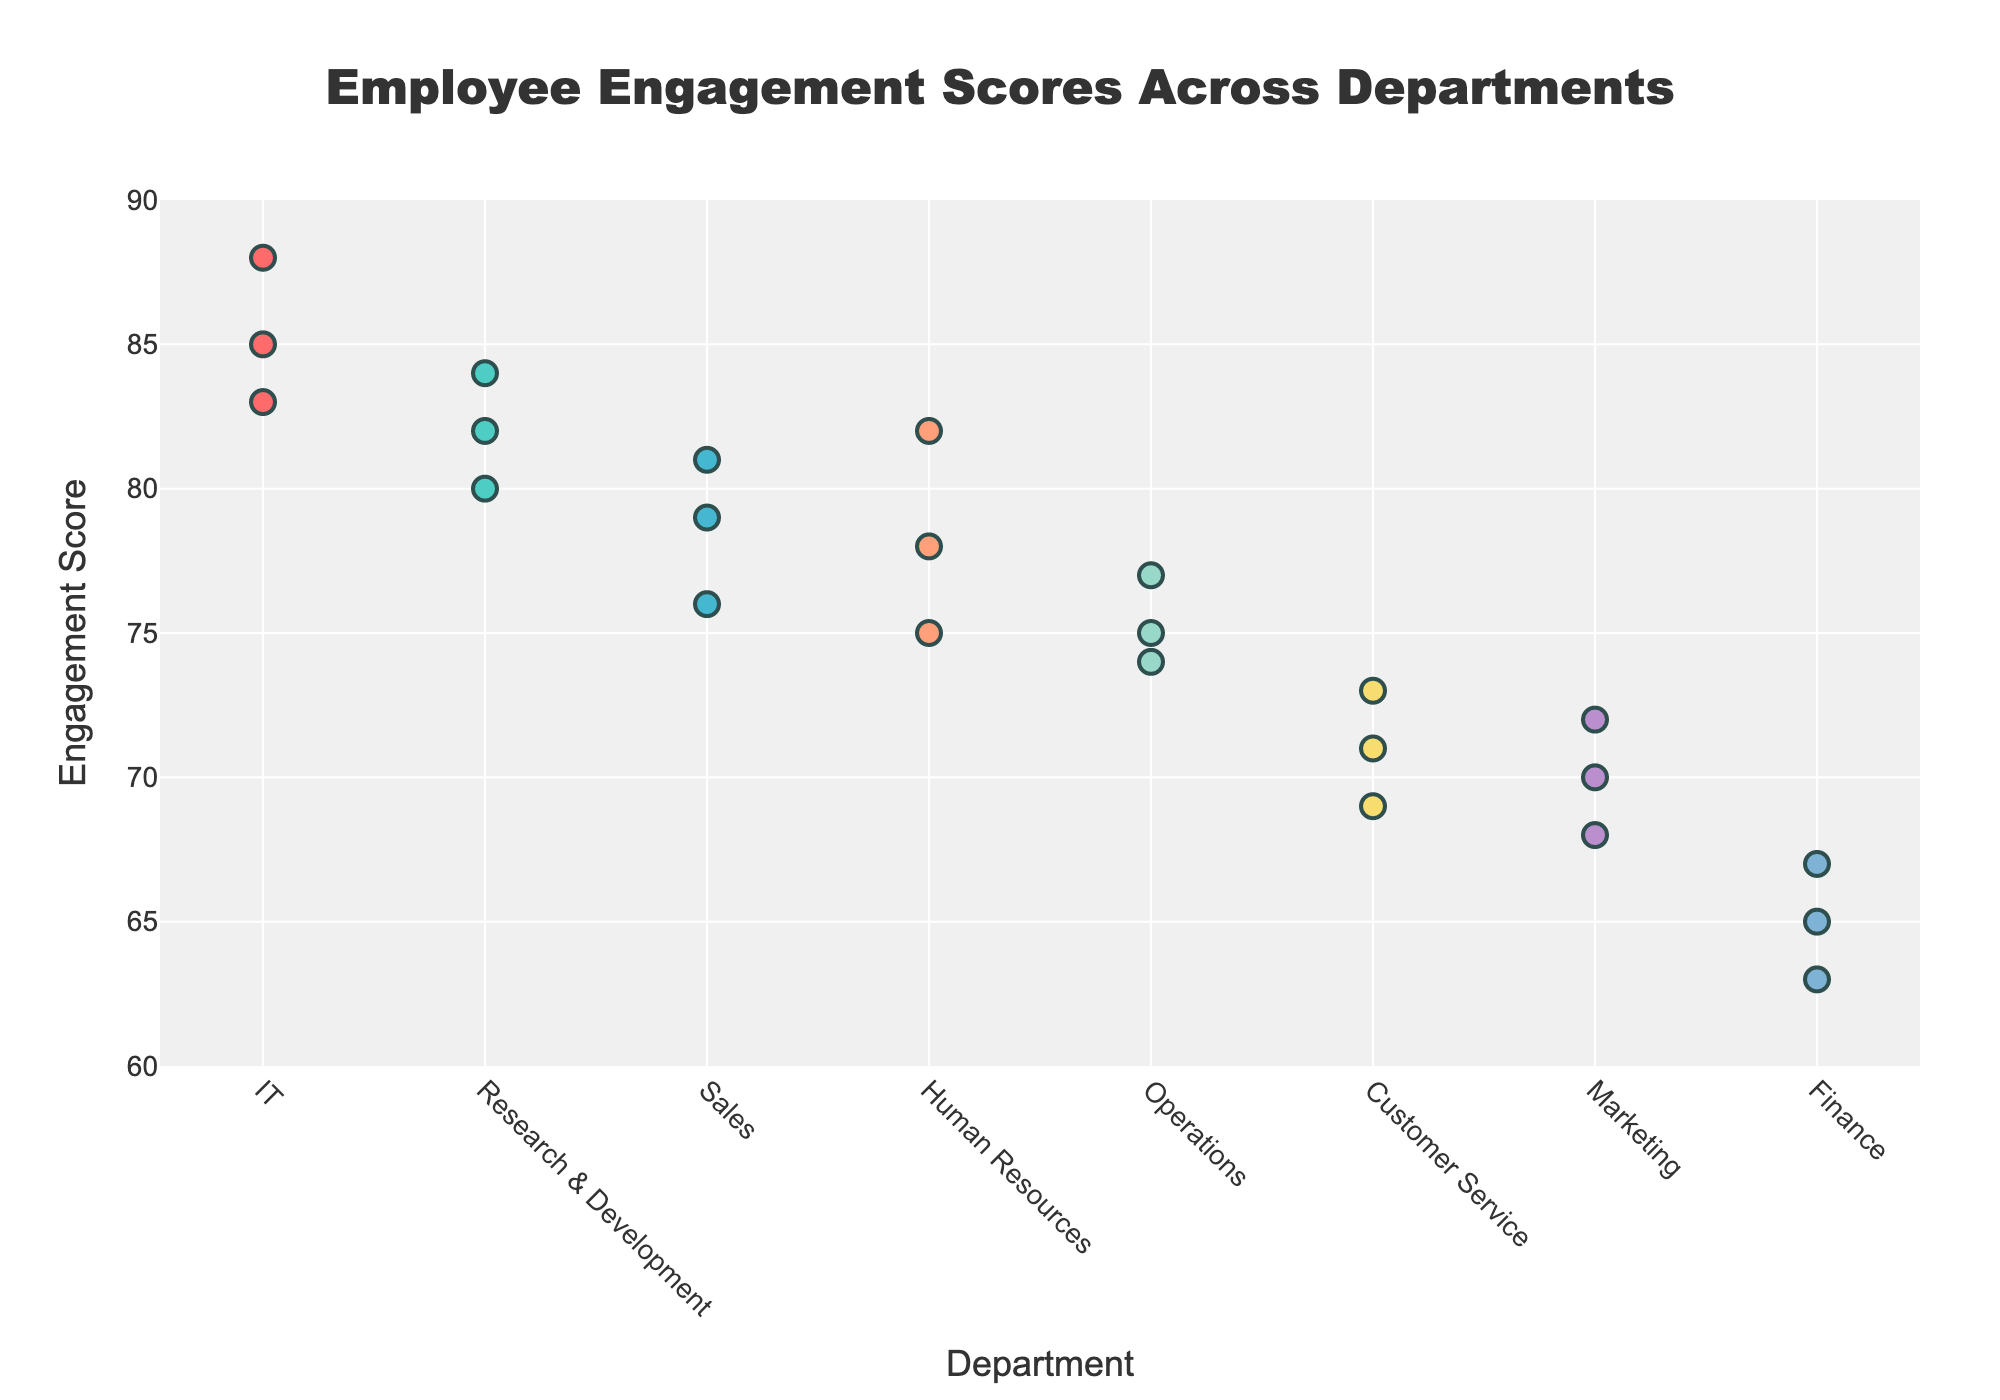What is the title of the plot? The title of the plot is displayed at the top.
Answer: Employee Engagement Scores Across Departments Which department shows the highest average engagement score? Identify the department with the highest plotted mean engagement score, indicated by the horizontal line.
Answer: IT What is the range of the y-axis? Look at the y-axis markers to determine the lowest and highest numerical values.
Answer: 60 to 90 How many departments have been plotted? Count the number of unique department names listed along the x-axis.
Answer: 8 What is the average engagement score for IT? Look at the position of the horizontal line for the IT department on the y-axis.
Answer: 85.33 Which department has the lowest average engagement score? Identify the department with the lowest plotted mean engagement score, indicated by the horizontal line.
Answer: Finance Are there any departments with the exact same mean engagement score? Compare the positions of the horizontal lines representing mean scores for each department to see if any overlap completely.
Answer: No Is there any noticeable trend in engagement scores across departments? Observe the scatter plot points and their distribution across the departments; some departments have higher or lower scores consistently.
Answer: Higher in IT and R&D, lower in Finance and Marketing Which department has a wider range of engagement scores based on the spread of points? Look at the scatter of the points for each department; the department with the most spread has the widest range.
Answer: Customer Service What is the mean score difference between IT and Finance departments? Subtract the mean score of Finance from the mean score of IT. IT has an average of 85.33, and Finance has 65; so the difference is 85.33 - 65.
Answer: 20.33 